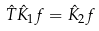<formula> <loc_0><loc_0><loc_500><loc_500>\hat { T } \hat { K } _ { 1 } f = \hat { K } _ { 2 } f</formula> 